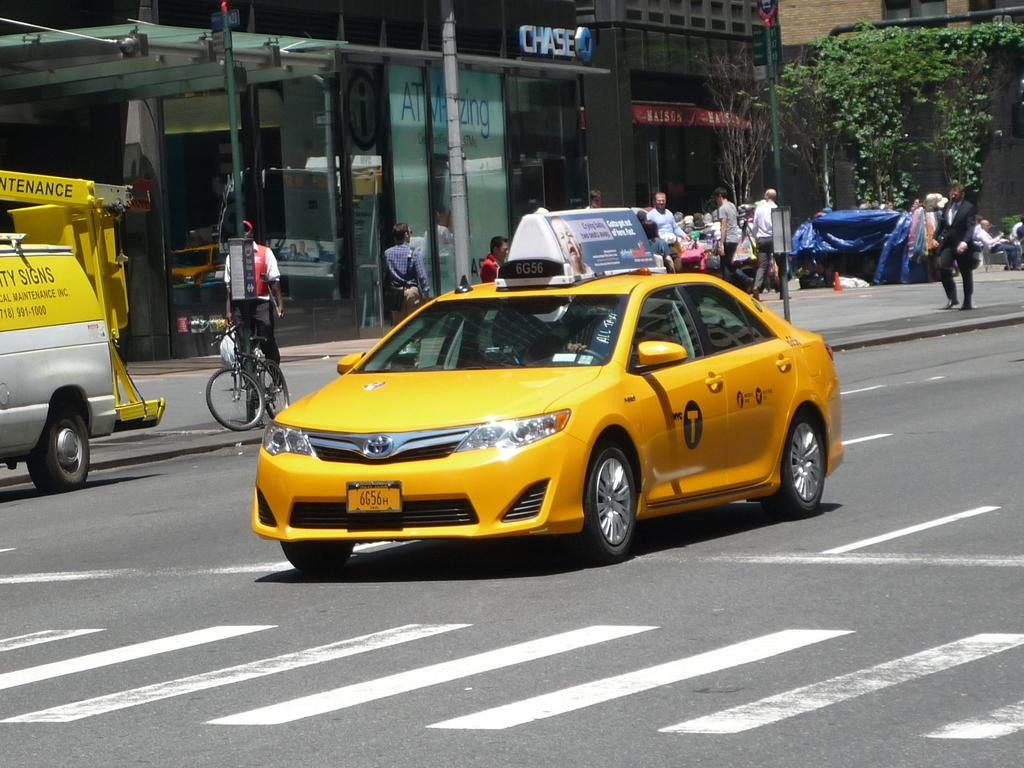Provide a one-sentence caption for the provided image. a cab that has the letter T on it. 